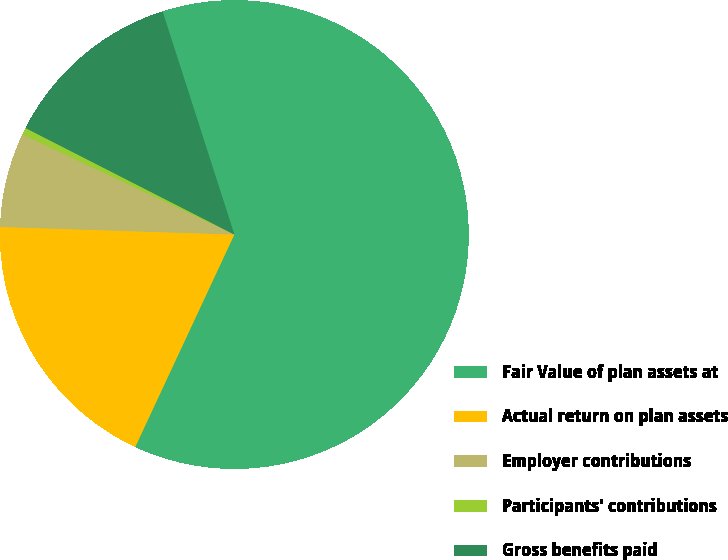Convert chart. <chart><loc_0><loc_0><loc_500><loc_500><pie_chart><fcel>Fair Value of plan assets at<fcel>Actual return on plan assets<fcel>Employer contributions<fcel>Participants' contributions<fcel>Gross benefits paid<nl><fcel>61.91%<fcel>18.57%<fcel>6.51%<fcel>0.48%<fcel>12.54%<nl></chart> 